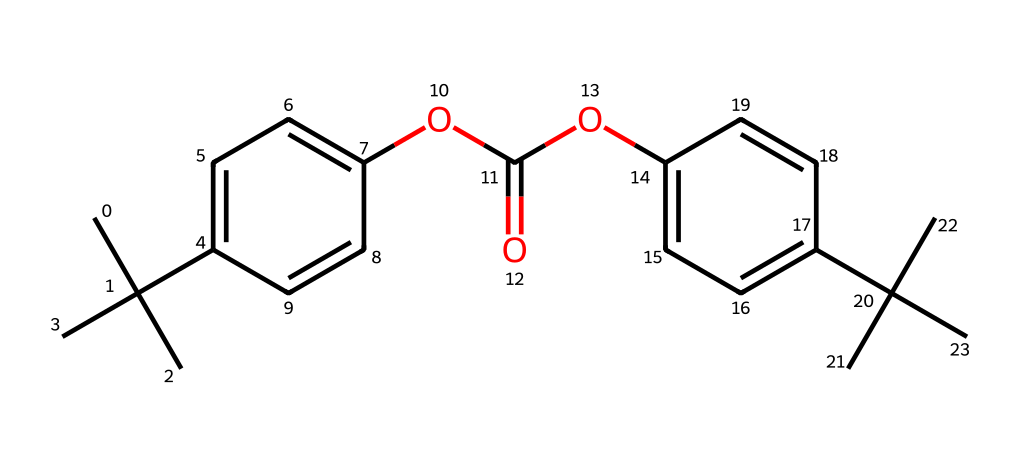What type of polymer is represented by this chemical structure? The structure shows repeating units typical of polycarbonate due to the presence of carbonate (OC(=O)O) moiety along with aromatic rings.
Answer: polycarbonate How many carbon atoms are present in this molecule? By counting the carbon atoms in the entire structure, including those in rings and branches, we find there are 23 carbon atoms.
Answer: 23 What functional groups are found in this chemical? The molecule contains ester functional groups (OC(=O)O) due to the presence of the carbonate linkage, as well as alkyl groups from the branched structures.
Answer: ester What is the primary characteristic that makes polycarbonate suitable for protective visors? Polycarbonate is known for its high impact resistance and clarity, which make it ideal for protective gear.
Answer: high impact resistance How many aromatic rings are present in this structure? The structure includes two distinct aromatic rings, evidenced by the c1ccc(cc1) and c2ccc(cc2) notations in the SMILES representation.
Answer: 2 What type of bonding is likely prevalent in this polymer? Given the presence of carbon and oxygen atoms in structure, covalent bonding is the primary type of bonding responsible for holding the molecular structure together.
Answer: covalent 